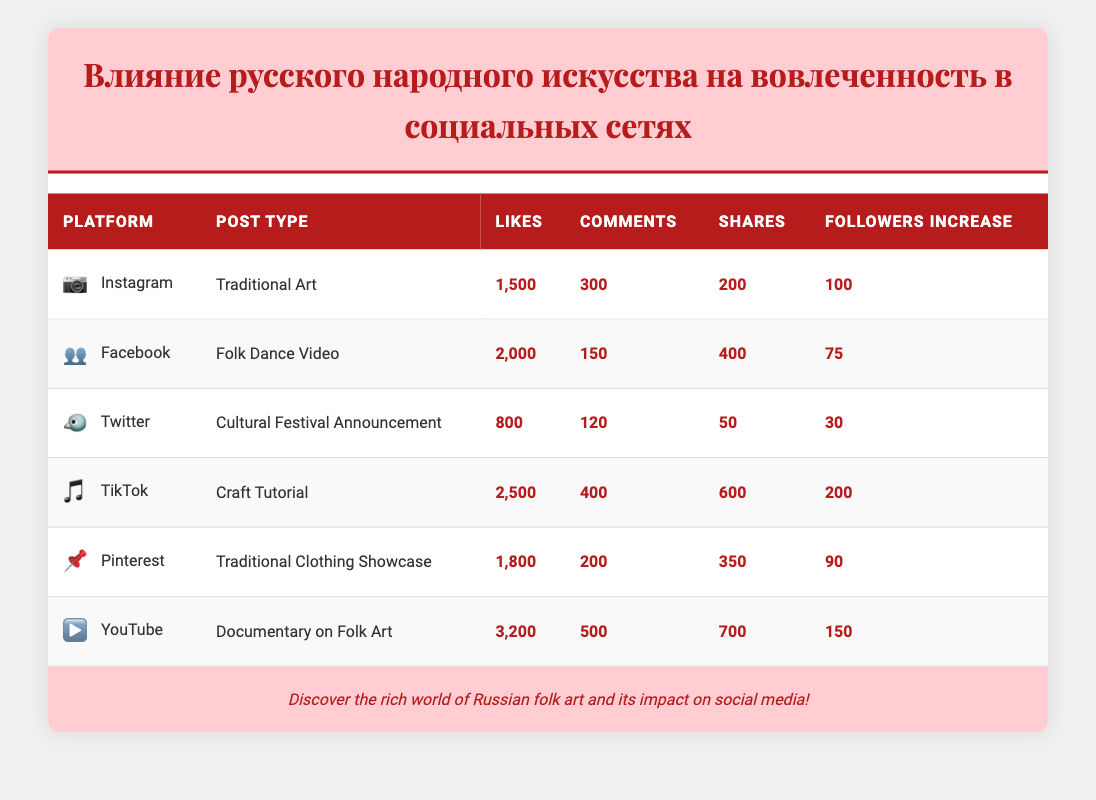What platform had the highest number of likes? The table shows that YouTube had the highest number of likes with 3,200, compared to other platforms listed, such as TikTok with 2,500, and Instagram with 1,500.
Answer: YouTube What is the total number of comments across all platforms? To find the total number of comments, add the comments from each platform: 300 (Instagram) + 150 (Facebook) + 120 (Twitter) + 400 (TikTok) + 200 (Pinterest) + 500 (YouTube) = 1,670.
Answer: 1,670 Did TikTok have more shares than Twitter? From the table, TikTok recorded 600 shares while Twitter only had 50 shares. Therefore, TikTok did indeed have more shares than Twitter.
Answer: Yes What is the difference in followers increase between Instagram and YouTube? The followers increase for Instagram is 100 and for YouTube, it is 150. To find the difference, subtract 100 from 150, resulting in 50.
Answer: 50 Which post type received the most engagement (likes + comments + shares) on Pinterest? For Pinterest, the engagement can be calculated by adding likes (1,800) + comments (200) + shares (350), totaling 2,350. This is the engagement metric for Pinterest specifically.
Answer: 2,350 How many platforms had more than 400 likes? By reviewing the likes for each platform: Instagram (1,500), Facebook (2,000), TikTok (2,500), Pinterest (1,800), and YouTube (3,200) all exceed 400 likes. Only Twitter, with 800 likes, also meets this criteria, giving us a total of 5 platforms.
Answer: 5 What is the average number of shares among all platforms? The total number of shares is 200 (Instagram) + 400 (Facebook) + 50 (Twitter) + 600 (TikTok) + 350 (Pinterest) + 700 (YouTube) = 2,300. With 6 platforms, the average number of shares is 2,300 divided by 6, which is approximately 383.33.
Answer: 383.33 Which platform had the least increase in followers? The table indicates that Twitter had the least increase in followers with 30 compared to other platforms, where the increases were 100 (Instagram), 75 (Facebook), 200 (TikTok), 90 (Pinterest), and 150 (YouTube).
Answer: Twitter 